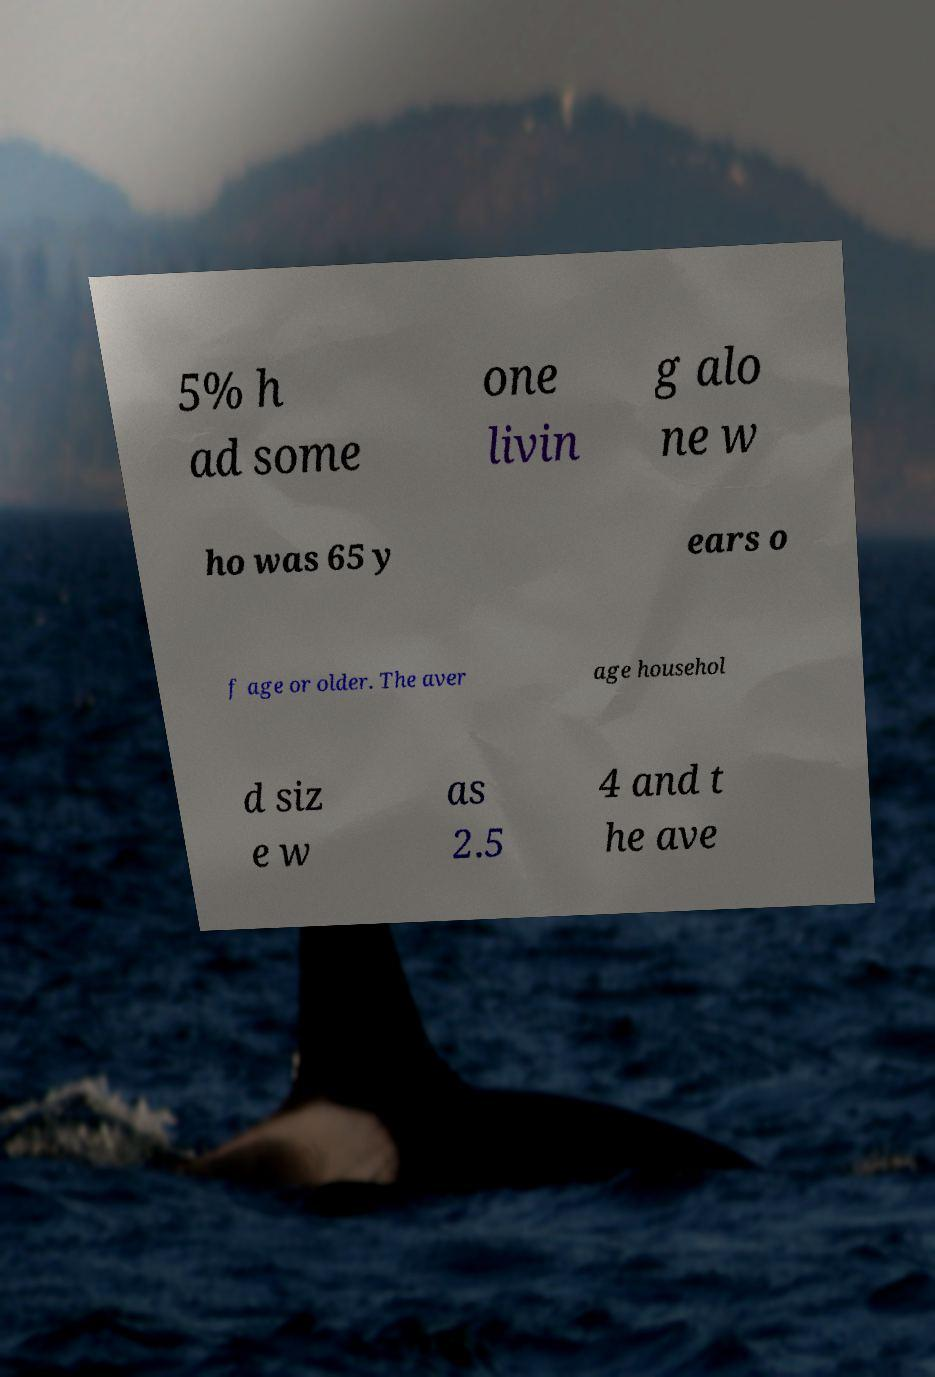I need the written content from this picture converted into text. Can you do that? 5% h ad some one livin g alo ne w ho was 65 y ears o f age or older. The aver age househol d siz e w as 2.5 4 and t he ave 